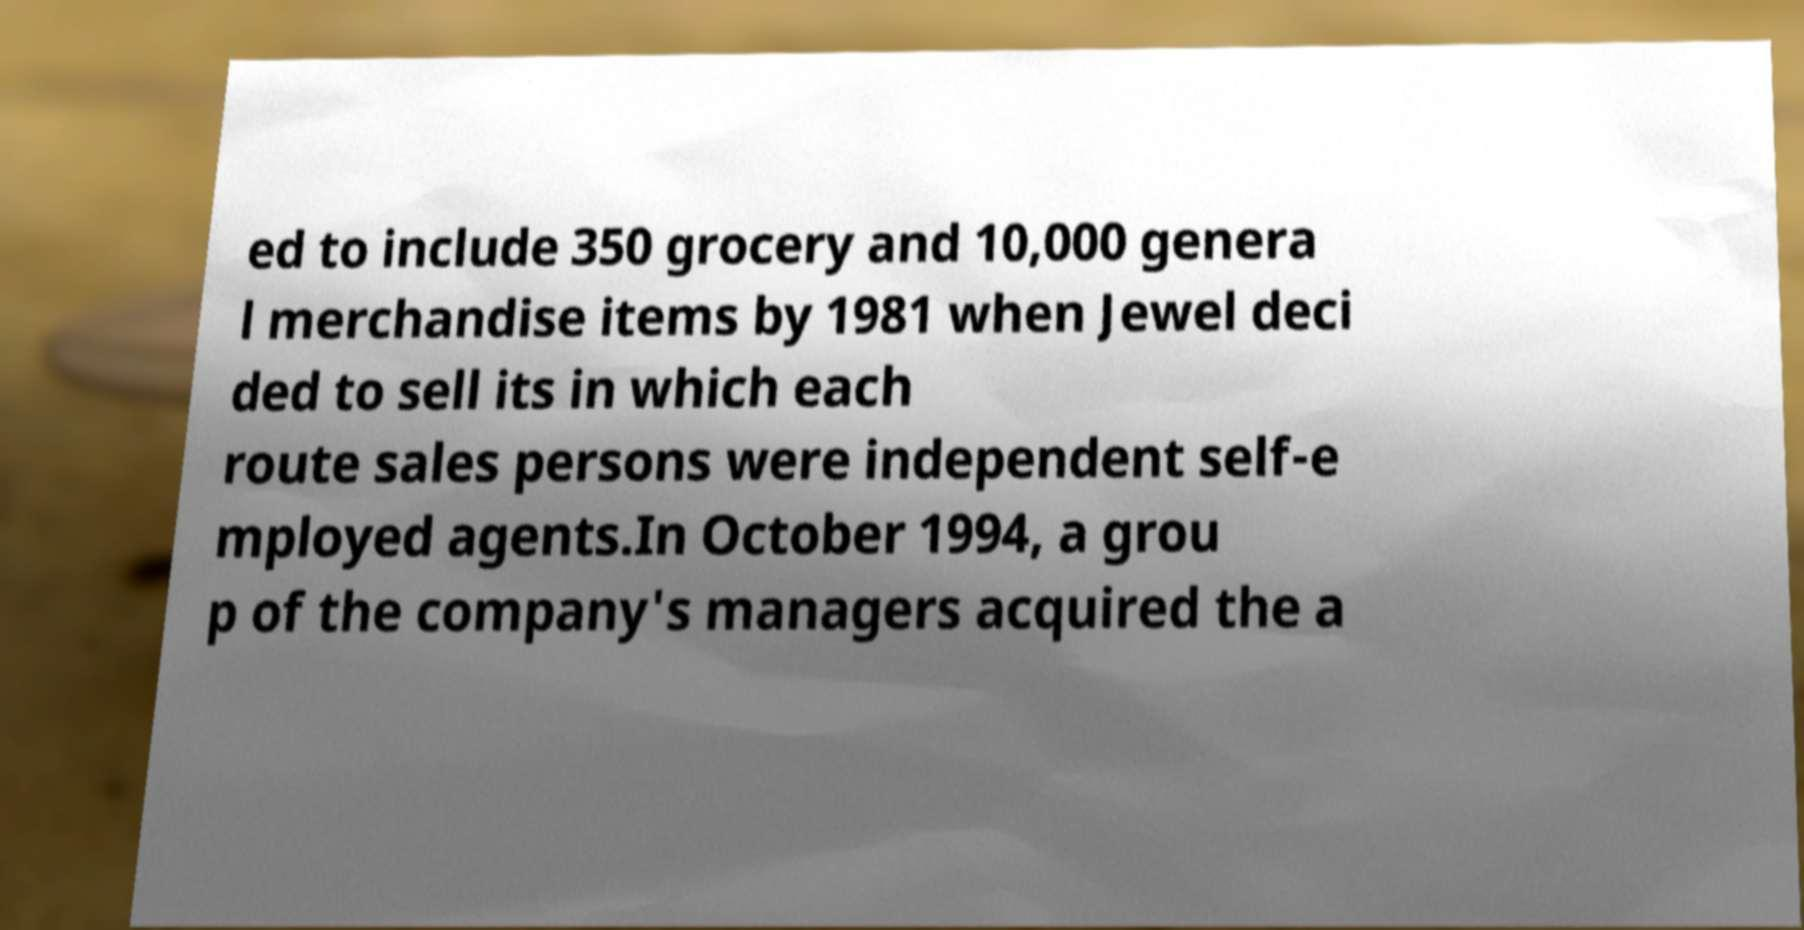Please identify and transcribe the text found in this image. ed to include 350 grocery and 10,000 genera l merchandise items by 1981 when Jewel deci ded to sell its in which each route sales persons were independent self-e mployed agents.In October 1994, a grou p of the company's managers acquired the a 